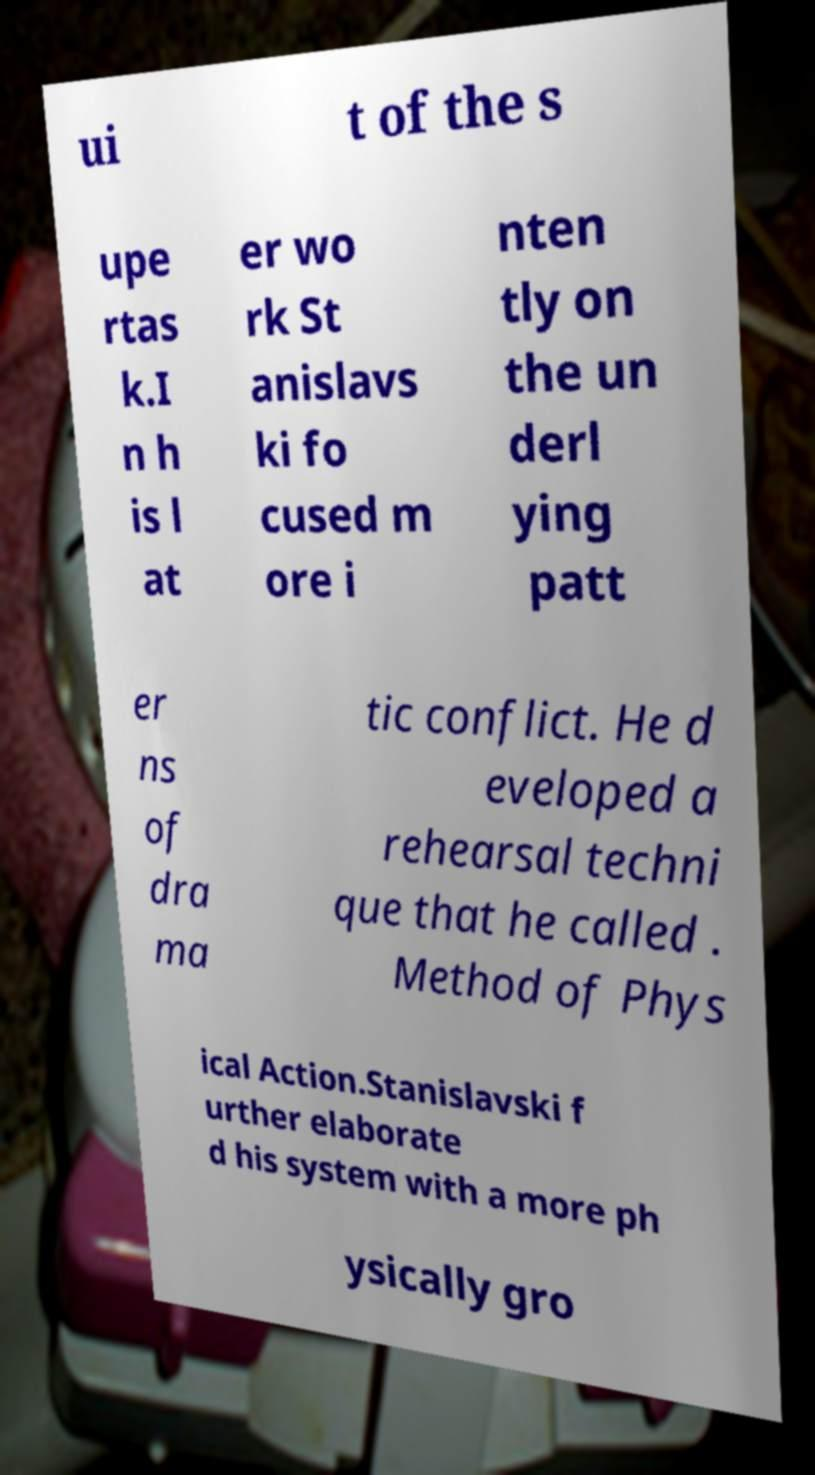Could you assist in decoding the text presented in this image and type it out clearly? ui t of the s upe rtas k.I n h is l at er wo rk St anislavs ki fo cused m ore i nten tly on the un derl ying patt er ns of dra ma tic conflict. He d eveloped a rehearsal techni que that he called . Method of Phys ical Action.Stanislavski f urther elaborate d his system with a more ph ysically gro 